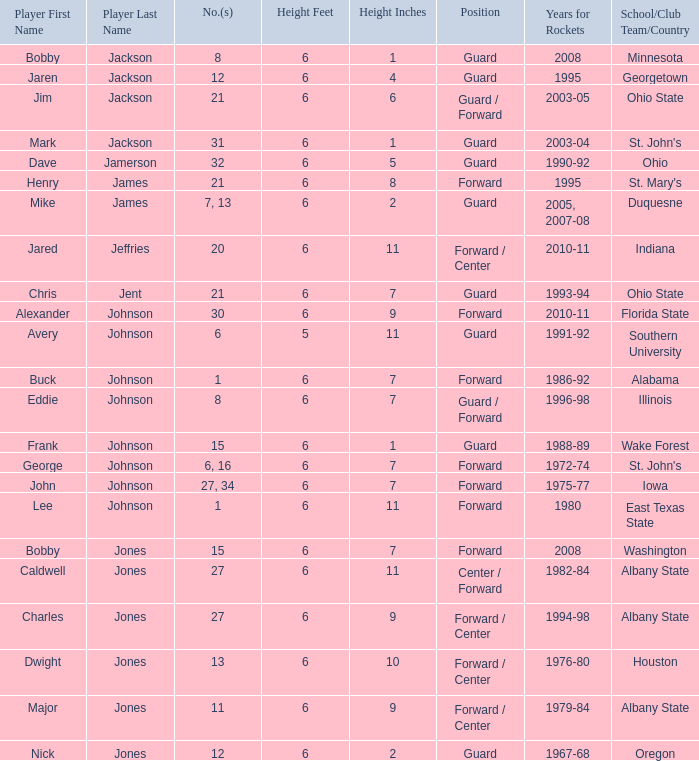Can you parse all the data within this table? {'header': ['Player First Name', 'Player Last Name', 'No.(s)', 'Height Feet', 'Height Inches', 'Position', 'Years for Rockets', 'School/Club Team/Country'], 'rows': [['Bobby', 'Jackson', '8', '6', '1', 'Guard', '2008', 'Minnesota'], ['Jaren', 'Jackson', '12', '6', '4', 'Guard', '1995', 'Georgetown'], ['Jim', 'Jackson', '21', '6', '6', 'Guard / Forward', '2003-05', 'Ohio State'], ['Mark', 'Jackson', '31', '6', '1', 'Guard', '2003-04', "St. John's"], ['Dave', 'Jamerson', '32', '6', '5', 'Guard', '1990-92', 'Ohio'], ['Henry', 'James', '21', '6', '8', 'Forward', '1995', "St. Mary's"], ['Mike', 'James', '7, 13', '6', '2', 'Guard', '2005, 2007-08', 'Duquesne'], ['Jared', 'Jeffries', '20', '6', '11', 'Forward / Center', '2010-11', 'Indiana'], ['Chris', 'Jent', '21', '6', '7', 'Guard', '1993-94', 'Ohio State'], ['Alexander', 'Johnson', '30', '6', '9', 'Forward', '2010-11', 'Florida State'], ['Avery', 'Johnson', '6', '5', '11', 'Guard', '1991-92', 'Southern University'], ['Buck', 'Johnson', '1', '6', '7', 'Forward', '1986-92', 'Alabama'], ['Eddie', 'Johnson', '8', '6', '7', 'Guard / Forward', '1996-98', 'Illinois'], ['Frank', 'Johnson', '15', '6', '1', 'Guard', '1988-89', 'Wake Forest'], ['George', 'Johnson', '6, 16', '6', '7', 'Forward', '1972-74', "St. John's"], ['John', 'Johnson', '27, 34', '6', '7', 'Forward', '1975-77', 'Iowa'], ['Lee', 'Johnson', '1', '6', '11', 'Forward', '1980', 'East Texas State'], ['Bobby', 'Jones', '15', '6', '7', 'Forward', '2008', 'Washington'], ['Caldwell', 'Jones', '27', '6', '11', 'Center / Forward', '1982-84', 'Albany State'], ['Charles', 'Jones', '27', '6', '9', 'Forward / Center', '1994-98', 'Albany State'], ['Dwight', 'Jones', '13', '6', '10', 'Forward / Center', '1976-80', 'Houston'], ['Major', 'Jones', '11', '6', '9', 'Forward / Center', '1979-84', 'Albany State'], ['Nick', 'Jones', '12', '6', '2', 'Guard', '1967-68', 'Oregon']]} Which player who played for the Rockets for the years 1986-92? Johnson, Buck Buck Johnson. 